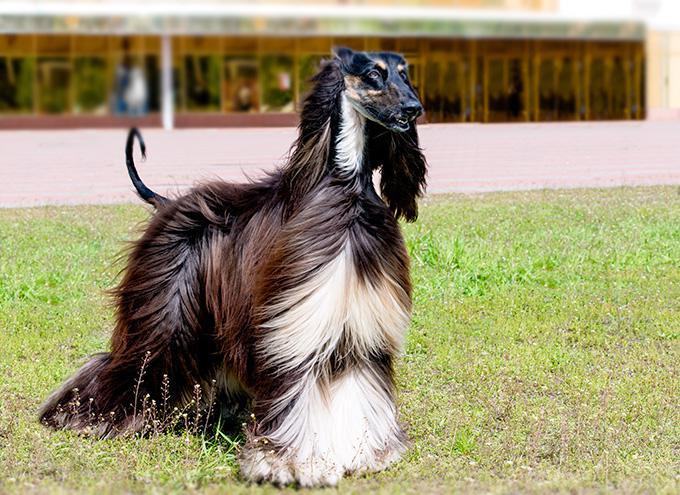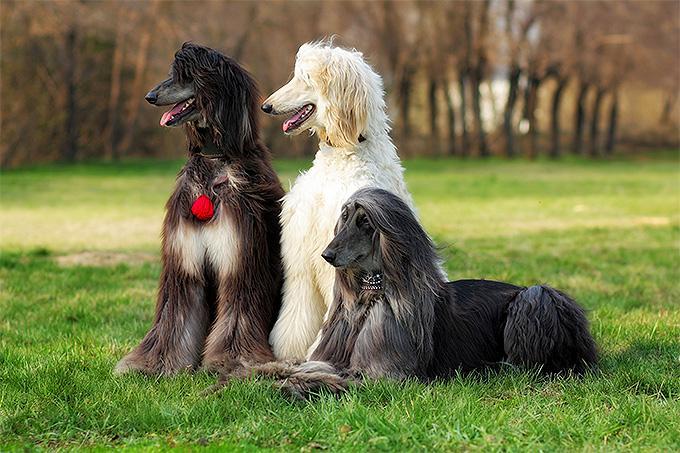The first image is the image on the left, the second image is the image on the right. For the images shown, is this caption "There is more than one dog in one of the images." true? Answer yes or no. Yes. The first image is the image on the left, the second image is the image on the right. Given the left and right images, does the statement "At least one dog is sitting upright in the grass." hold true? Answer yes or no. Yes. 